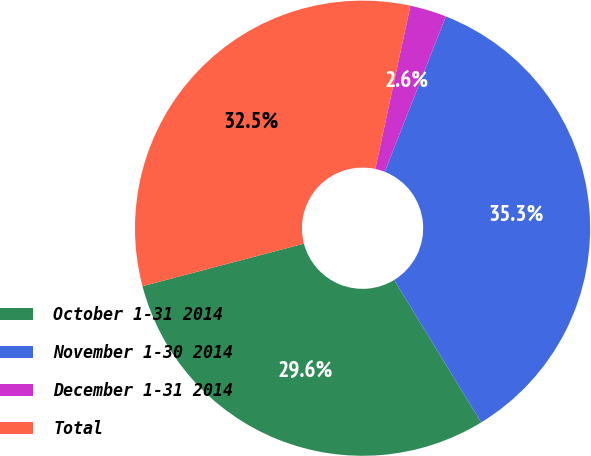Convert chart to OTSL. <chart><loc_0><loc_0><loc_500><loc_500><pie_chart><fcel>October 1-31 2014<fcel>November 1-30 2014<fcel>December 1-31 2014<fcel>Total<nl><fcel>29.63%<fcel>35.31%<fcel>2.59%<fcel>32.47%<nl></chart> 